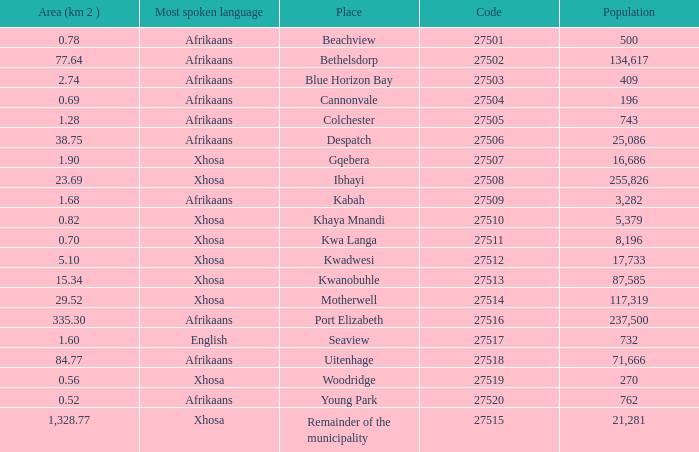What is the total number of area listed for cannonvale with a population less than 409? 1.0. 